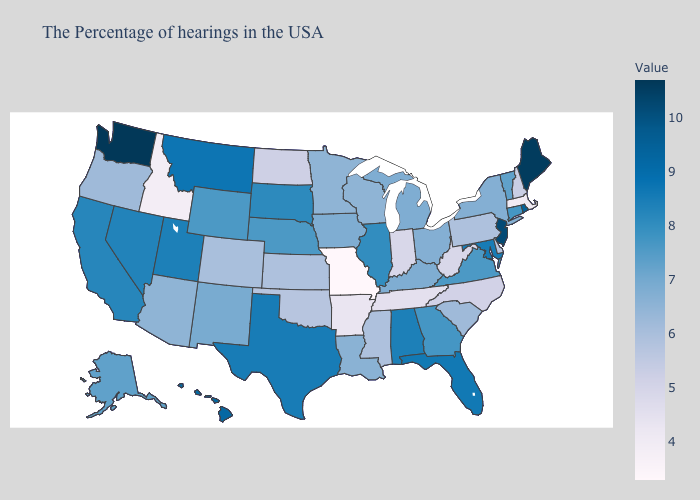Which states have the lowest value in the USA?
Concise answer only. Missouri. Among the states that border New Mexico , does Arizona have the highest value?
Write a very short answer. No. Is the legend a continuous bar?
Concise answer only. Yes. Which states have the highest value in the USA?
Short answer required. Washington. Which states have the lowest value in the West?
Be succinct. Idaho. 